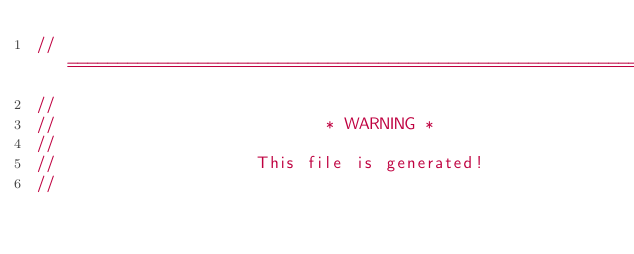<code> <loc_0><loc_0><loc_500><loc_500><_Rust_>// =================================================================
//
//                           * WARNING *
//
//                    This file is generated!
//</code> 